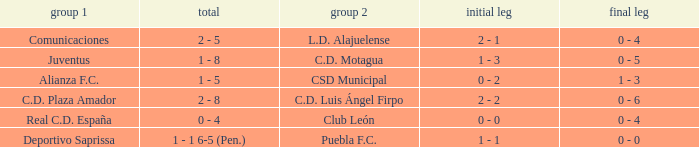What is the 2nd leg of the Comunicaciones team? 0 - 4. 